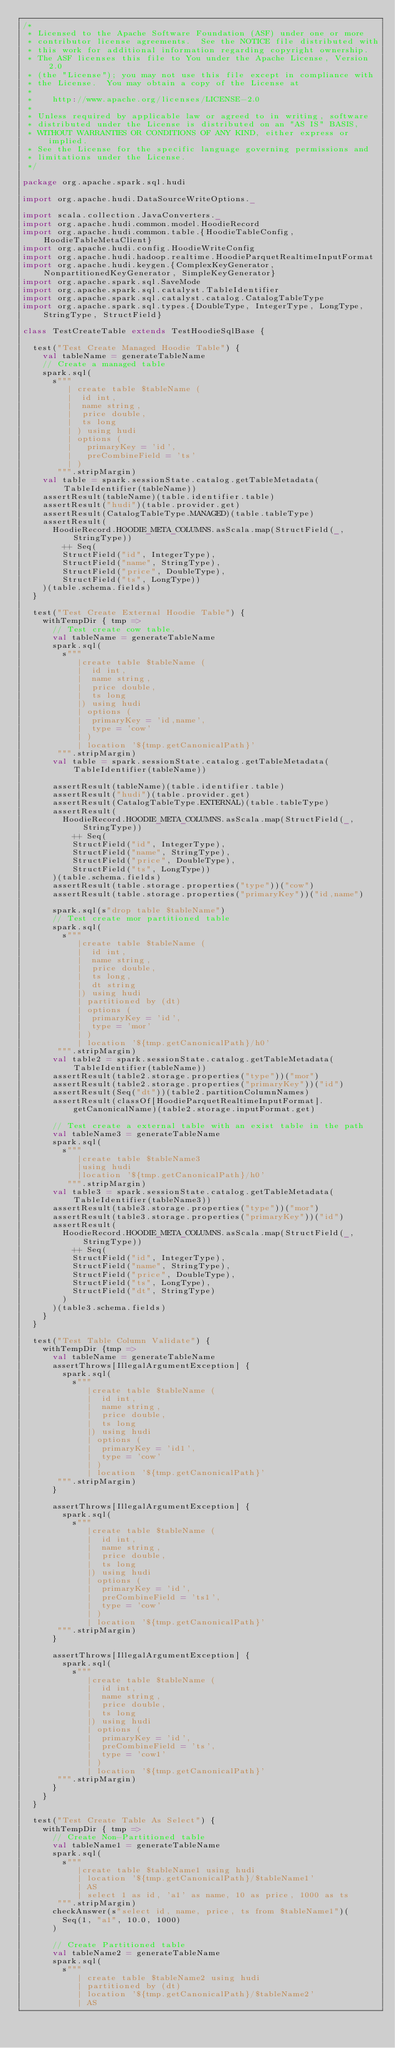Convert code to text. <code><loc_0><loc_0><loc_500><loc_500><_Scala_>/*
 * Licensed to the Apache Software Foundation (ASF) under one or more
 * contributor license agreements.  See the NOTICE file distributed with
 * this work for additional information regarding copyright ownership.
 * The ASF licenses this file to You under the Apache License, Version 2.0
 * (the "License"); you may not use this file except in compliance with
 * the License.  You may obtain a copy of the License at
 *
 *    http://www.apache.org/licenses/LICENSE-2.0
 *
 * Unless required by applicable law or agreed to in writing, software
 * distributed under the License is distributed on an "AS IS" BASIS,
 * WITHOUT WARRANTIES OR CONDITIONS OF ANY KIND, either express or implied.
 * See the License for the specific language governing permissions and
 * limitations under the License.
 */

package org.apache.spark.sql.hudi

import org.apache.hudi.DataSourceWriteOptions._

import scala.collection.JavaConverters._
import org.apache.hudi.common.model.HoodieRecord
import org.apache.hudi.common.table.{HoodieTableConfig, HoodieTableMetaClient}
import org.apache.hudi.config.HoodieWriteConfig
import org.apache.hudi.hadoop.realtime.HoodieParquetRealtimeInputFormat
import org.apache.hudi.keygen.{ComplexKeyGenerator, NonpartitionedKeyGenerator, SimpleKeyGenerator}
import org.apache.spark.sql.SaveMode
import org.apache.spark.sql.catalyst.TableIdentifier
import org.apache.spark.sql.catalyst.catalog.CatalogTableType
import org.apache.spark.sql.types.{DoubleType, IntegerType, LongType, StringType, StructField}

class TestCreateTable extends TestHoodieSqlBase {

  test("Test Create Managed Hoodie Table") {
    val tableName = generateTableName
    // Create a managed table
    spark.sql(
      s"""
         | create table $tableName (
         |  id int,
         |  name string,
         |  price double,
         |  ts long
         | ) using hudi
         | options (
         |   primaryKey = 'id',
         |   preCombineField = 'ts'
         | )
       """.stripMargin)
    val table = spark.sessionState.catalog.getTableMetadata(TableIdentifier(tableName))
    assertResult(tableName)(table.identifier.table)
    assertResult("hudi")(table.provider.get)
    assertResult(CatalogTableType.MANAGED)(table.tableType)
    assertResult(
      HoodieRecord.HOODIE_META_COLUMNS.asScala.map(StructField(_, StringType))
        ++ Seq(
        StructField("id", IntegerType),
        StructField("name", StringType),
        StructField("price", DoubleType),
        StructField("ts", LongType))
    )(table.schema.fields)
  }

  test("Test Create External Hoodie Table") {
    withTempDir { tmp =>
      // Test create cow table.
      val tableName = generateTableName
      spark.sql(
        s"""
           |create table $tableName (
           |  id int,
           |  name string,
           |  price double,
           |  ts long
           |) using hudi
           | options (
           |  primaryKey = 'id,name',
           |  type = 'cow'
           | )
           | location '${tmp.getCanonicalPath}'
       """.stripMargin)
      val table = spark.sessionState.catalog.getTableMetadata(TableIdentifier(tableName))

      assertResult(tableName)(table.identifier.table)
      assertResult("hudi")(table.provider.get)
      assertResult(CatalogTableType.EXTERNAL)(table.tableType)
      assertResult(
        HoodieRecord.HOODIE_META_COLUMNS.asScala.map(StructField(_, StringType))
          ++ Seq(
          StructField("id", IntegerType),
          StructField("name", StringType),
          StructField("price", DoubleType),
          StructField("ts", LongType))
      )(table.schema.fields)
      assertResult(table.storage.properties("type"))("cow")
      assertResult(table.storage.properties("primaryKey"))("id,name")

      spark.sql(s"drop table $tableName")
      // Test create mor partitioned table
      spark.sql(
        s"""
           |create table $tableName (
           |  id int,
           |  name string,
           |  price double,
           |  ts long,
           |  dt string
           |) using hudi
           | partitioned by (dt)
           | options (
           |  primaryKey = 'id',
           |  type = 'mor'
           | )
           | location '${tmp.getCanonicalPath}/h0'
       """.stripMargin)
      val table2 = spark.sessionState.catalog.getTableMetadata(TableIdentifier(tableName))
      assertResult(table2.storage.properties("type"))("mor")
      assertResult(table2.storage.properties("primaryKey"))("id")
      assertResult(Seq("dt"))(table2.partitionColumnNames)
      assertResult(classOf[HoodieParquetRealtimeInputFormat].getCanonicalName)(table2.storage.inputFormat.get)

      // Test create a external table with an exist table in the path
      val tableName3 = generateTableName
      spark.sql(
        s"""
           |create table $tableName3
           |using hudi
           |location '${tmp.getCanonicalPath}/h0'
         """.stripMargin)
      val table3 = spark.sessionState.catalog.getTableMetadata(TableIdentifier(tableName3))
      assertResult(table3.storage.properties("type"))("mor")
      assertResult(table3.storage.properties("primaryKey"))("id")
      assertResult(
        HoodieRecord.HOODIE_META_COLUMNS.asScala.map(StructField(_, StringType))
          ++ Seq(
          StructField("id", IntegerType),
          StructField("name", StringType),
          StructField("price", DoubleType),
          StructField("ts", LongType),
          StructField("dt", StringType)
        )
      )(table3.schema.fields)
    }
  }

  test("Test Table Column Validate") {
    withTempDir {tmp =>
      val tableName = generateTableName
      assertThrows[IllegalArgumentException] {
        spark.sql(
          s"""
             |create table $tableName (
             |  id int,
             |  name string,
             |  price double,
             |  ts long
             |) using hudi
             | options (
             |  primaryKey = 'id1',
             |  type = 'cow'
             | )
             | location '${tmp.getCanonicalPath}'
       """.stripMargin)
      }

      assertThrows[IllegalArgumentException] {
        spark.sql(
          s"""
             |create table $tableName (
             |  id int,
             |  name string,
             |  price double,
             |  ts long
             |) using hudi
             | options (
             |  primaryKey = 'id',
             |  preCombineField = 'ts1',
             |  type = 'cow'
             | )
             | location '${tmp.getCanonicalPath}'
       """.stripMargin)
      }

      assertThrows[IllegalArgumentException] {
        spark.sql(
          s"""
             |create table $tableName (
             |  id int,
             |  name string,
             |  price double,
             |  ts long
             |) using hudi
             | options (
             |  primaryKey = 'id',
             |  preCombineField = 'ts',
             |  type = 'cow1'
             | )
             | location '${tmp.getCanonicalPath}'
       """.stripMargin)
      }
    }
  }

  test("Test Create Table As Select") {
    withTempDir { tmp =>
      // Create Non-Partitioned table
      val tableName1 = generateTableName
      spark.sql(
        s"""
           |create table $tableName1 using hudi
           | location '${tmp.getCanonicalPath}/$tableName1'
           | AS
           | select 1 as id, 'a1' as name, 10 as price, 1000 as ts
       """.stripMargin)
      checkAnswer(s"select id, name, price, ts from $tableName1")(
        Seq(1, "a1", 10.0, 1000)
      )

      // Create Partitioned table
      val tableName2 = generateTableName
      spark.sql(
        s"""
           | create table $tableName2 using hudi
           | partitioned by (dt)
           | location '${tmp.getCanonicalPath}/$tableName2'
           | AS</code> 